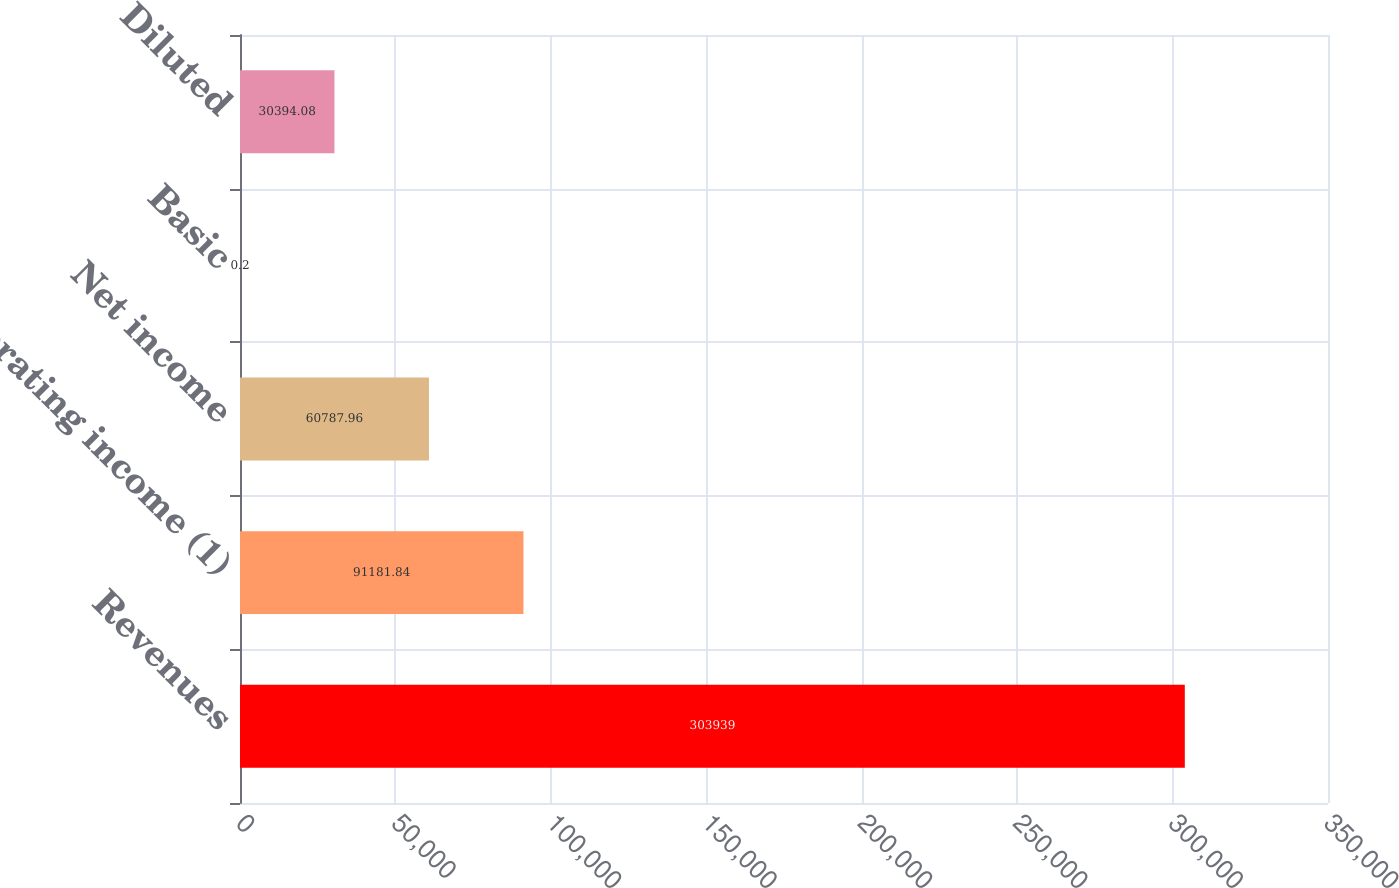Convert chart. <chart><loc_0><loc_0><loc_500><loc_500><bar_chart><fcel>Revenues<fcel>Operating income (1)<fcel>Net income<fcel>Basic<fcel>Diluted<nl><fcel>303939<fcel>91181.8<fcel>60788<fcel>0.2<fcel>30394.1<nl></chart> 